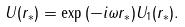Convert formula to latex. <formula><loc_0><loc_0><loc_500><loc_500>U ( r _ { * } ) = \exp { ( - i \omega r _ { * } ) } U _ { 1 } ( r _ { * } ) .</formula> 